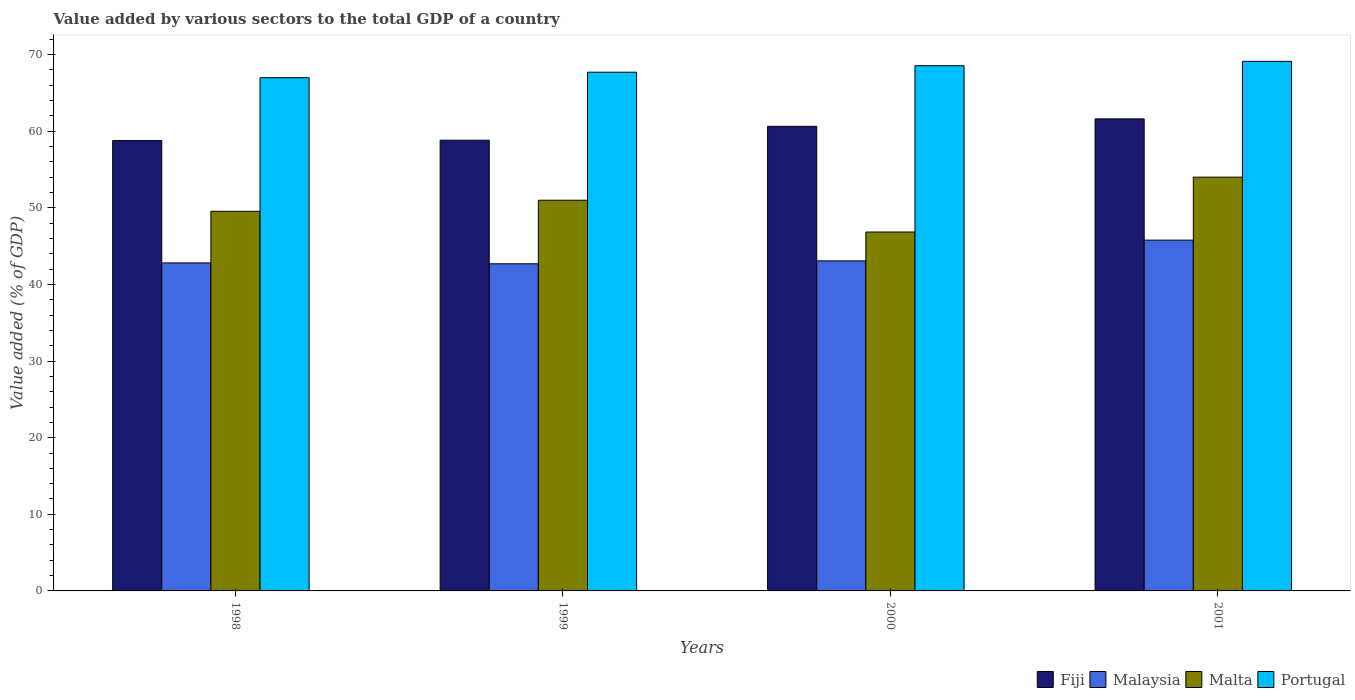Are the number of bars per tick equal to the number of legend labels?
Ensure brevity in your answer.  Yes. Are the number of bars on each tick of the X-axis equal?
Make the answer very short. Yes. What is the label of the 4th group of bars from the left?
Keep it short and to the point. 2001. What is the value added by various sectors to the total GDP in Fiji in 1998?
Keep it short and to the point. 58.78. Across all years, what is the maximum value added by various sectors to the total GDP in Malta?
Your answer should be very brief. 54.01. Across all years, what is the minimum value added by various sectors to the total GDP in Malta?
Ensure brevity in your answer.  46.85. In which year was the value added by various sectors to the total GDP in Fiji maximum?
Your answer should be compact. 2001. What is the total value added by various sectors to the total GDP in Portugal in the graph?
Make the answer very short. 272.36. What is the difference between the value added by various sectors to the total GDP in Fiji in 1998 and that in 2001?
Offer a very short reply. -2.83. What is the difference between the value added by various sectors to the total GDP in Fiji in 2000 and the value added by various sectors to the total GDP in Portugal in 2001?
Provide a succinct answer. -8.48. What is the average value added by various sectors to the total GDP in Portugal per year?
Your answer should be compact. 68.09. In the year 2001, what is the difference between the value added by various sectors to the total GDP in Fiji and value added by various sectors to the total GDP in Malta?
Your response must be concise. 7.6. In how many years, is the value added by various sectors to the total GDP in Malta greater than 64 %?
Your response must be concise. 0. What is the ratio of the value added by various sectors to the total GDP in Malaysia in 1998 to that in 2001?
Provide a succinct answer. 0.94. Is the value added by various sectors to the total GDP in Fiji in 2000 less than that in 2001?
Offer a terse response. Yes. Is the difference between the value added by various sectors to the total GDP in Fiji in 1999 and 2001 greater than the difference between the value added by various sectors to the total GDP in Malta in 1999 and 2001?
Your response must be concise. Yes. What is the difference between the highest and the second highest value added by various sectors to the total GDP in Malaysia?
Offer a very short reply. 2.7. What is the difference between the highest and the lowest value added by various sectors to the total GDP in Malaysia?
Provide a succinct answer. 3.09. In how many years, is the value added by various sectors to the total GDP in Malta greater than the average value added by various sectors to the total GDP in Malta taken over all years?
Your answer should be compact. 2. Is the sum of the value added by various sectors to the total GDP in Malaysia in 1999 and 2001 greater than the maximum value added by various sectors to the total GDP in Fiji across all years?
Give a very brief answer. Yes. Is it the case that in every year, the sum of the value added by various sectors to the total GDP in Malta and value added by various sectors to the total GDP in Fiji is greater than the sum of value added by various sectors to the total GDP in Malaysia and value added by various sectors to the total GDP in Portugal?
Provide a succinct answer. Yes. What does the 1st bar from the left in 1999 represents?
Make the answer very short. Fiji. What does the 1st bar from the right in 2001 represents?
Your answer should be very brief. Portugal. How many bars are there?
Offer a terse response. 16. Are all the bars in the graph horizontal?
Your response must be concise. No. How many years are there in the graph?
Provide a succinct answer. 4. Are the values on the major ticks of Y-axis written in scientific E-notation?
Offer a terse response. No. Does the graph contain any zero values?
Your response must be concise. No. What is the title of the graph?
Give a very brief answer. Value added by various sectors to the total GDP of a country. What is the label or title of the Y-axis?
Your answer should be compact. Value added (% of GDP). What is the Value added (% of GDP) in Fiji in 1998?
Your answer should be very brief. 58.78. What is the Value added (% of GDP) of Malaysia in 1998?
Your answer should be very brief. 42.81. What is the Value added (% of GDP) in Malta in 1998?
Your response must be concise. 49.55. What is the Value added (% of GDP) of Portugal in 1998?
Keep it short and to the point. 66.99. What is the Value added (% of GDP) of Fiji in 1999?
Provide a short and direct response. 58.83. What is the Value added (% of GDP) in Malaysia in 1999?
Provide a short and direct response. 42.7. What is the Value added (% of GDP) in Malta in 1999?
Ensure brevity in your answer.  50.99. What is the Value added (% of GDP) in Portugal in 1999?
Make the answer very short. 67.7. What is the Value added (% of GDP) in Fiji in 2000?
Ensure brevity in your answer.  60.64. What is the Value added (% of GDP) in Malaysia in 2000?
Give a very brief answer. 43.08. What is the Value added (% of GDP) of Malta in 2000?
Keep it short and to the point. 46.85. What is the Value added (% of GDP) of Portugal in 2000?
Offer a terse response. 68.55. What is the Value added (% of GDP) of Fiji in 2001?
Provide a succinct answer. 61.61. What is the Value added (% of GDP) of Malaysia in 2001?
Provide a short and direct response. 45.79. What is the Value added (% of GDP) of Malta in 2001?
Offer a terse response. 54.01. What is the Value added (% of GDP) in Portugal in 2001?
Keep it short and to the point. 69.12. Across all years, what is the maximum Value added (% of GDP) of Fiji?
Your answer should be very brief. 61.61. Across all years, what is the maximum Value added (% of GDP) in Malaysia?
Offer a very short reply. 45.79. Across all years, what is the maximum Value added (% of GDP) of Malta?
Provide a short and direct response. 54.01. Across all years, what is the maximum Value added (% of GDP) of Portugal?
Give a very brief answer. 69.12. Across all years, what is the minimum Value added (% of GDP) of Fiji?
Ensure brevity in your answer.  58.78. Across all years, what is the minimum Value added (% of GDP) of Malaysia?
Give a very brief answer. 42.7. Across all years, what is the minimum Value added (% of GDP) of Malta?
Your response must be concise. 46.85. Across all years, what is the minimum Value added (% of GDP) in Portugal?
Your answer should be compact. 66.99. What is the total Value added (% of GDP) in Fiji in the graph?
Make the answer very short. 239.86. What is the total Value added (% of GDP) in Malaysia in the graph?
Your response must be concise. 174.38. What is the total Value added (% of GDP) of Malta in the graph?
Give a very brief answer. 201.39. What is the total Value added (% of GDP) in Portugal in the graph?
Offer a very short reply. 272.36. What is the difference between the Value added (% of GDP) in Fiji in 1998 and that in 1999?
Provide a short and direct response. -0.05. What is the difference between the Value added (% of GDP) of Malaysia in 1998 and that in 1999?
Your answer should be compact. 0.11. What is the difference between the Value added (% of GDP) in Malta in 1998 and that in 1999?
Your answer should be very brief. -1.44. What is the difference between the Value added (% of GDP) in Portugal in 1998 and that in 1999?
Give a very brief answer. -0.72. What is the difference between the Value added (% of GDP) of Fiji in 1998 and that in 2000?
Make the answer very short. -1.86. What is the difference between the Value added (% of GDP) in Malaysia in 1998 and that in 2000?
Ensure brevity in your answer.  -0.27. What is the difference between the Value added (% of GDP) of Malta in 1998 and that in 2000?
Make the answer very short. 2.7. What is the difference between the Value added (% of GDP) of Portugal in 1998 and that in 2000?
Make the answer very short. -1.56. What is the difference between the Value added (% of GDP) in Fiji in 1998 and that in 2001?
Give a very brief answer. -2.83. What is the difference between the Value added (% of GDP) of Malaysia in 1998 and that in 2001?
Offer a terse response. -2.97. What is the difference between the Value added (% of GDP) of Malta in 1998 and that in 2001?
Your answer should be compact. -4.45. What is the difference between the Value added (% of GDP) of Portugal in 1998 and that in 2001?
Offer a terse response. -2.13. What is the difference between the Value added (% of GDP) of Fiji in 1999 and that in 2000?
Provide a succinct answer. -1.81. What is the difference between the Value added (% of GDP) in Malaysia in 1999 and that in 2000?
Your answer should be compact. -0.38. What is the difference between the Value added (% of GDP) in Malta in 1999 and that in 2000?
Give a very brief answer. 4.15. What is the difference between the Value added (% of GDP) in Portugal in 1999 and that in 2000?
Your answer should be very brief. -0.85. What is the difference between the Value added (% of GDP) in Fiji in 1999 and that in 2001?
Keep it short and to the point. -2.78. What is the difference between the Value added (% of GDP) in Malaysia in 1999 and that in 2001?
Offer a very short reply. -3.09. What is the difference between the Value added (% of GDP) in Malta in 1999 and that in 2001?
Offer a terse response. -3.01. What is the difference between the Value added (% of GDP) in Portugal in 1999 and that in 2001?
Give a very brief answer. -1.41. What is the difference between the Value added (% of GDP) in Fiji in 2000 and that in 2001?
Make the answer very short. -0.97. What is the difference between the Value added (% of GDP) in Malaysia in 2000 and that in 2001?
Your answer should be very brief. -2.7. What is the difference between the Value added (% of GDP) of Malta in 2000 and that in 2001?
Offer a terse response. -7.16. What is the difference between the Value added (% of GDP) in Portugal in 2000 and that in 2001?
Offer a very short reply. -0.57. What is the difference between the Value added (% of GDP) in Fiji in 1998 and the Value added (% of GDP) in Malaysia in 1999?
Make the answer very short. 16.08. What is the difference between the Value added (% of GDP) in Fiji in 1998 and the Value added (% of GDP) in Malta in 1999?
Keep it short and to the point. 7.79. What is the difference between the Value added (% of GDP) in Fiji in 1998 and the Value added (% of GDP) in Portugal in 1999?
Provide a succinct answer. -8.93. What is the difference between the Value added (% of GDP) of Malaysia in 1998 and the Value added (% of GDP) of Malta in 1999?
Your answer should be compact. -8.18. What is the difference between the Value added (% of GDP) of Malaysia in 1998 and the Value added (% of GDP) of Portugal in 1999?
Make the answer very short. -24.89. What is the difference between the Value added (% of GDP) in Malta in 1998 and the Value added (% of GDP) in Portugal in 1999?
Offer a terse response. -18.15. What is the difference between the Value added (% of GDP) in Fiji in 1998 and the Value added (% of GDP) in Malaysia in 2000?
Keep it short and to the point. 15.7. What is the difference between the Value added (% of GDP) of Fiji in 1998 and the Value added (% of GDP) of Malta in 2000?
Offer a terse response. 11.93. What is the difference between the Value added (% of GDP) in Fiji in 1998 and the Value added (% of GDP) in Portugal in 2000?
Your response must be concise. -9.77. What is the difference between the Value added (% of GDP) of Malaysia in 1998 and the Value added (% of GDP) of Malta in 2000?
Provide a short and direct response. -4.03. What is the difference between the Value added (% of GDP) in Malaysia in 1998 and the Value added (% of GDP) in Portugal in 2000?
Provide a short and direct response. -25.74. What is the difference between the Value added (% of GDP) of Malta in 1998 and the Value added (% of GDP) of Portugal in 2000?
Provide a short and direct response. -19. What is the difference between the Value added (% of GDP) of Fiji in 1998 and the Value added (% of GDP) of Malaysia in 2001?
Offer a very short reply. 12.99. What is the difference between the Value added (% of GDP) of Fiji in 1998 and the Value added (% of GDP) of Malta in 2001?
Give a very brief answer. 4.77. What is the difference between the Value added (% of GDP) in Fiji in 1998 and the Value added (% of GDP) in Portugal in 2001?
Your answer should be very brief. -10.34. What is the difference between the Value added (% of GDP) of Malaysia in 1998 and the Value added (% of GDP) of Malta in 2001?
Give a very brief answer. -11.19. What is the difference between the Value added (% of GDP) of Malaysia in 1998 and the Value added (% of GDP) of Portugal in 2001?
Your answer should be compact. -26.31. What is the difference between the Value added (% of GDP) of Malta in 1998 and the Value added (% of GDP) of Portugal in 2001?
Make the answer very short. -19.57. What is the difference between the Value added (% of GDP) of Fiji in 1999 and the Value added (% of GDP) of Malaysia in 2000?
Your answer should be compact. 15.75. What is the difference between the Value added (% of GDP) in Fiji in 1999 and the Value added (% of GDP) in Malta in 2000?
Provide a short and direct response. 11.98. What is the difference between the Value added (% of GDP) of Fiji in 1999 and the Value added (% of GDP) of Portugal in 2000?
Your response must be concise. -9.72. What is the difference between the Value added (% of GDP) of Malaysia in 1999 and the Value added (% of GDP) of Malta in 2000?
Your response must be concise. -4.15. What is the difference between the Value added (% of GDP) in Malaysia in 1999 and the Value added (% of GDP) in Portugal in 2000?
Offer a very short reply. -25.85. What is the difference between the Value added (% of GDP) in Malta in 1999 and the Value added (% of GDP) in Portugal in 2000?
Ensure brevity in your answer.  -17.56. What is the difference between the Value added (% of GDP) in Fiji in 1999 and the Value added (% of GDP) in Malaysia in 2001?
Ensure brevity in your answer.  13.04. What is the difference between the Value added (% of GDP) of Fiji in 1999 and the Value added (% of GDP) of Malta in 2001?
Keep it short and to the point. 4.82. What is the difference between the Value added (% of GDP) in Fiji in 1999 and the Value added (% of GDP) in Portugal in 2001?
Provide a short and direct response. -10.29. What is the difference between the Value added (% of GDP) in Malaysia in 1999 and the Value added (% of GDP) in Malta in 2001?
Provide a succinct answer. -11.31. What is the difference between the Value added (% of GDP) of Malaysia in 1999 and the Value added (% of GDP) of Portugal in 2001?
Your answer should be very brief. -26.42. What is the difference between the Value added (% of GDP) of Malta in 1999 and the Value added (% of GDP) of Portugal in 2001?
Make the answer very short. -18.13. What is the difference between the Value added (% of GDP) in Fiji in 2000 and the Value added (% of GDP) in Malaysia in 2001?
Offer a very short reply. 14.86. What is the difference between the Value added (% of GDP) of Fiji in 2000 and the Value added (% of GDP) of Malta in 2001?
Your answer should be compact. 6.64. What is the difference between the Value added (% of GDP) of Fiji in 2000 and the Value added (% of GDP) of Portugal in 2001?
Your answer should be compact. -8.48. What is the difference between the Value added (% of GDP) of Malaysia in 2000 and the Value added (% of GDP) of Malta in 2001?
Provide a short and direct response. -10.92. What is the difference between the Value added (% of GDP) of Malaysia in 2000 and the Value added (% of GDP) of Portugal in 2001?
Your answer should be very brief. -26.04. What is the difference between the Value added (% of GDP) of Malta in 2000 and the Value added (% of GDP) of Portugal in 2001?
Give a very brief answer. -22.27. What is the average Value added (% of GDP) in Fiji per year?
Keep it short and to the point. 59.96. What is the average Value added (% of GDP) of Malaysia per year?
Offer a terse response. 43.59. What is the average Value added (% of GDP) in Malta per year?
Offer a very short reply. 50.35. What is the average Value added (% of GDP) of Portugal per year?
Offer a terse response. 68.09. In the year 1998, what is the difference between the Value added (% of GDP) of Fiji and Value added (% of GDP) of Malaysia?
Offer a very short reply. 15.97. In the year 1998, what is the difference between the Value added (% of GDP) in Fiji and Value added (% of GDP) in Malta?
Keep it short and to the point. 9.23. In the year 1998, what is the difference between the Value added (% of GDP) of Fiji and Value added (% of GDP) of Portugal?
Your answer should be very brief. -8.21. In the year 1998, what is the difference between the Value added (% of GDP) in Malaysia and Value added (% of GDP) in Malta?
Provide a succinct answer. -6.74. In the year 1998, what is the difference between the Value added (% of GDP) of Malaysia and Value added (% of GDP) of Portugal?
Provide a short and direct response. -24.18. In the year 1998, what is the difference between the Value added (% of GDP) of Malta and Value added (% of GDP) of Portugal?
Ensure brevity in your answer.  -17.44. In the year 1999, what is the difference between the Value added (% of GDP) of Fiji and Value added (% of GDP) of Malaysia?
Ensure brevity in your answer.  16.13. In the year 1999, what is the difference between the Value added (% of GDP) of Fiji and Value added (% of GDP) of Malta?
Your answer should be very brief. 7.84. In the year 1999, what is the difference between the Value added (% of GDP) in Fiji and Value added (% of GDP) in Portugal?
Provide a succinct answer. -8.88. In the year 1999, what is the difference between the Value added (% of GDP) of Malaysia and Value added (% of GDP) of Malta?
Make the answer very short. -8.29. In the year 1999, what is the difference between the Value added (% of GDP) of Malaysia and Value added (% of GDP) of Portugal?
Give a very brief answer. -25.01. In the year 1999, what is the difference between the Value added (% of GDP) of Malta and Value added (% of GDP) of Portugal?
Make the answer very short. -16.71. In the year 2000, what is the difference between the Value added (% of GDP) in Fiji and Value added (% of GDP) in Malaysia?
Offer a terse response. 17.56. In the year 2000, what is the difference between the Value added (% of GDP) of Fiji and Value added (% of GDP) of Malta?
Give a very brief answer. 13.8. In the year 2000, what is the difference between the Value added (% of GDP) of Fiji and Value added (% of GDP) of Portugal?
Your answer should be very brief. -7.91. In the year 2000, what is the difference between the Value added (% of GDP) of Malaysia and Value added (% of GDP) of Malta?
Ensure brevity in your answer.  -3.76. In the year 2000, what is the difference between the Value added (% of GDP) of Malaysia and Value added (% of GDP) of Portugal?
Your answer should be very brief. -25.47. In the year 2000, what is the difference between the Value added (% of GDP) in Malta and Value added (% of GDP) in Portugal?
Give a very brief answer. -21.7. In the year 2001, what is the difference between the Value added (% of GDP) in Fiji and Value added (% of GDP) in Malaysia?
Offer a terse response. 15.82. In the year 2001, what is the difference between the Value added (% of GDP) in Fiji and Value added (% of GDP) in Malta?
Offer a terse response. 7.6. In the year 2001, what is the difference between the Value added (% of GDP) in Fiji and Value added (% of GDP) in Portugal?
Your response must be concise. -7.51. In the year 2001, what is the difference between the Value added (% of GDP) in Malaysia and Value added (% of GDP) in Malta?
Offer a very short reply. -8.22. In the year 2001, what is the difference between the Value added (% of GDP) of Malaysia and Value added (% of GDP) of Portugal?
Offer a very short reply. -23.33. In the year 2001, what is the difference between the Value added (% of GDP) in Malta and Value added (% of GDP) in Portugal?
Make the answer very short. -15.11. What is the ratio of the Value added (% of GDP) of Fiji in 1998 to that in 1999?
Your answer should be very brief. 1. What is the ratio of the Value added (% of GDP) of Malaysia in 1998 to that in 1999?
Ensure brevity in your answer.  1. What is the ratio of the Value added (% of GDP) in Malta in 1998 to that in 1999?
Your answer should be compact. 0.97. What is the ratio of the Value added (% of GDP) in Portugal in 1998 to that in 1999?
Your response must be concise. 0.99. What is the ratio of the Value added (% of GDP) in Fiji in 1998 to that in 2000?
Provide a short and direct response. 0.97. What is the ratio of the Value added (% of GDP) in Malta in 1998 to that in 2000?
Your answer should be very brief. 1.06. What is the ratio of the Value added (% of GDP) in Portugal in 1998 to that in 2000?
Offer a very short reply. 0.98. What is the ratio of the Value added (% of GDP) of Fiji in 1998 to that in 2001?
Provide a short and direct response. 0.95. What is the ratio of the Value added (% of GDP) in Malaysia in 1998 to that in 2001?
Keep it short and to the point. 0.94. What is the ratio of the Value added (% of GDP) of Malta in 1998 to that in 2001?
Your answer should be compact. 0.92. What is the ratio of the Value added (% of GDP) in Portugal in 1998 to that in 2001?
Your answer should be very brief. 0.97. What is the ratio of the Value added (% of GDP) in Fiji in 1999 to that in 2000?
Keep it short and to the point. 0.97. What is the ratio of the Value added (% of GDP) in Malaysia in 1999 to that in 2000?
Offer a terse response. 0.99. What is the ratio of the Value added (% of GDP) of Malta in 1999 to that in 2000?
Your answer should be compact. 1.09. What is the ratio of the Value added (% of GDP) of Portugal in 1999 to that in 2000?
Make the answer very short. 0.99. What is the ratio of the Value added (% of GDP) in Fiji in 1999 to that in 2001?
Your answer should be compact. 0.95. What is the ratio of the Value added (% of GDP) in Malaysia in 1999 to that in 2001?
Offer a very short reply. 0.93. What is the ratio of the Value added (% of GDP) in Malta in 1999 to that in 2001?
Make the answer very short. 0.94. What is the ratio of the Value added (% of GDP) of Portugal in 1999 to that in 2001?
Ensure brevity in your answer.  0.98. What is the ratio of the Value added (% of GDP) of Fiji in 2000 to that in 2001?
Give a very brief answer. 0.98. What is the ratio of the Value added (% of GDP) in Malaysia in 2000 to that in 2001?
Offer a terse response. 0.94. What is the ratio of the Value added (% of GDP) of Malta in 2000 to that in 2001?
Provide a succinct answer. 0.87. What is the difference between the highest and the second highest Value added (% of GDP) in Fiji?
Give a very brief answer. 0.97. What is the difference between the highest and the second highest Value added (% of GDP) of Malaysia?
Provide a short and direct response. 2.7. What is the difference between the highest and the second highest Value added (% of GDP) in Malta?
Ensure brevity in your answer.  3.01. What is the difference between the highest and the second highest Value added (% of GDP) in Portugal?
Ensure brevity in your answer.  0.57. What is the difference between the highest and the lowest Value added (% of GDP) in Fiji?
Offer a very short reply. 2.83. What is the difference between the highest and the lowest Value added (% of GDP) in Malaysia?
Your answer should be compact. 3.09. What is the difference between the highest and the lowest Value added (% of GDP) in Malta?
Your answer should be very brief. 7.16. What is the difference between the highest and the lowest Value added (% of GDP) of Portugal?
Offer a very short reply. 2.13. 